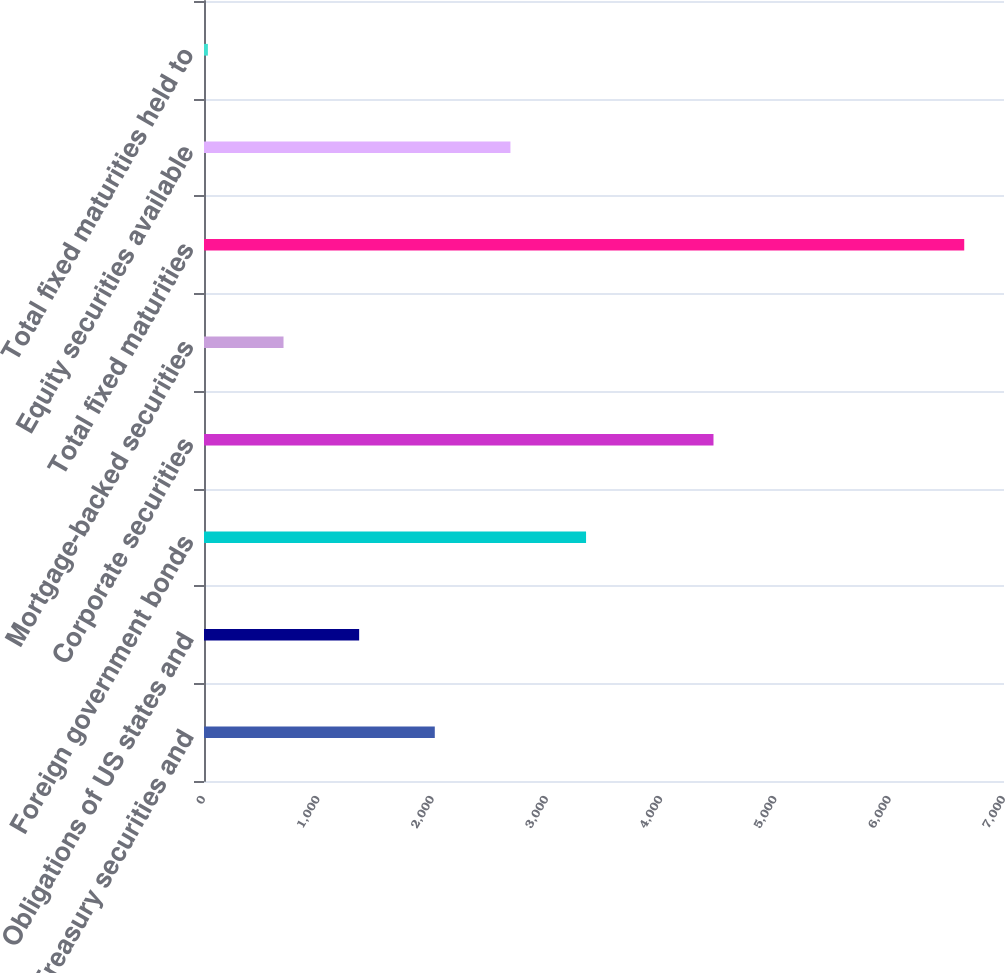<chart> <loc_0><loc_0><loc_500><loc_500><bar_chart><fcel>US Treasury securities and<fcel>Obligations of US states and<fcel>Foreign government bonds<fcel>Corporate securities<fcel>Mortgage-backed securities<fcel>Total fixed maturities<fcel>Equity securities available<fcel>Total fixed maturities held to<nl><fcel>2019.4<fcel>1357.6<fcel>3343<fcel>4458<fcel>695.8<fcel>6652<fcel>2681.2<fcel>34<nl></chart> 